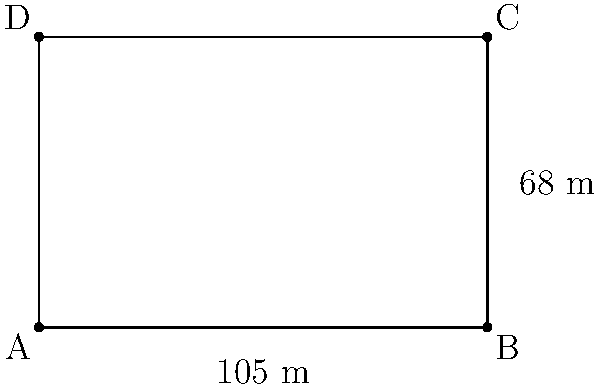As a dedicated fan of Slawi United F.C., you're curious about the dimensions of your team's home pitch. The field is rectangular, measuring 105 meters in length and 68 meters in width. What is the perimeter of the soccer field at Slawi United's home stadium? To find the perimeter of the rectangular soccer field, we need to follow these steps:

1. Identify the length and width of the field:
   Length = 105 meters
   Width = 68 meters

2. Recall the formula for the perimeter of a rectangle:
   Perimeter = 2 × (length + width)

3. Substitute the values into the formula:
   Perimeter = 2 × (105 m + 68 m)

4. Calculate the sum inside the parentheses:
   Perimeter = 2 × 173 m

5. Multiply to get the final result:
   Perimeter = 346 meters

Therefore, the perimeter of the soccer field at Slawi United's home stadium is 346 meters.
Answer: 346 meters 